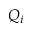<formula> <loc_0><loc_0><loc_500><loc_500>Q _ { i }</formula> 